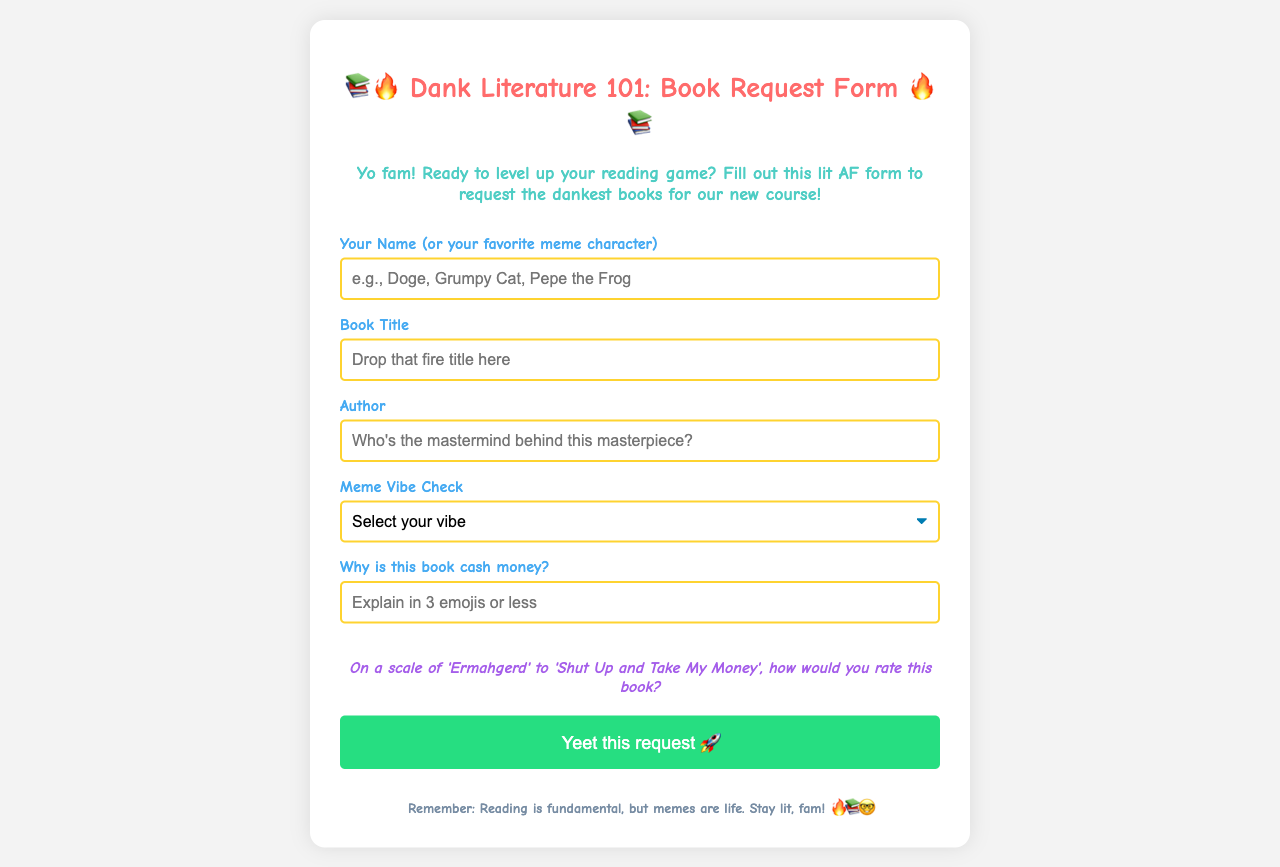What is the title of the form? The title of the form is stated at the top of the document, "Dank Literature 101: Book Request Form."
Answer: Dank Literature 101: Book Request Form What emoji is used in the title? The title includes two emojis, fire (🔥) and book (📚).
Answer: 📚🔥 What is the purpose of the form? The document states that the purpose is to request books for a course, indicating users should fill it out for that reason.
Answer: Request books for a course How many options are available for the meme vibe check? The document lists five different options in the drop-down for meme vibe check.
Answer: Five What is the maximum number of emojis allowed in the cash money explanation? The form specifies a limit to the number of emojis permissible in the "cash money" explanation.
Answer: Three Who can submit a book request? The form asks for the name or a favorite meme character, indicating anyone can submit if they comply.
Answer: Anyone What phrase is used to encourage submitting the request? The document provides an enthusiastic prompt at the end of the form encouraging submission.
Answer: Yeet this request What is the underlying theme of the document? The entire document has a humorous and informal tone centered around memes and literature.
Answer: Memes and literature 